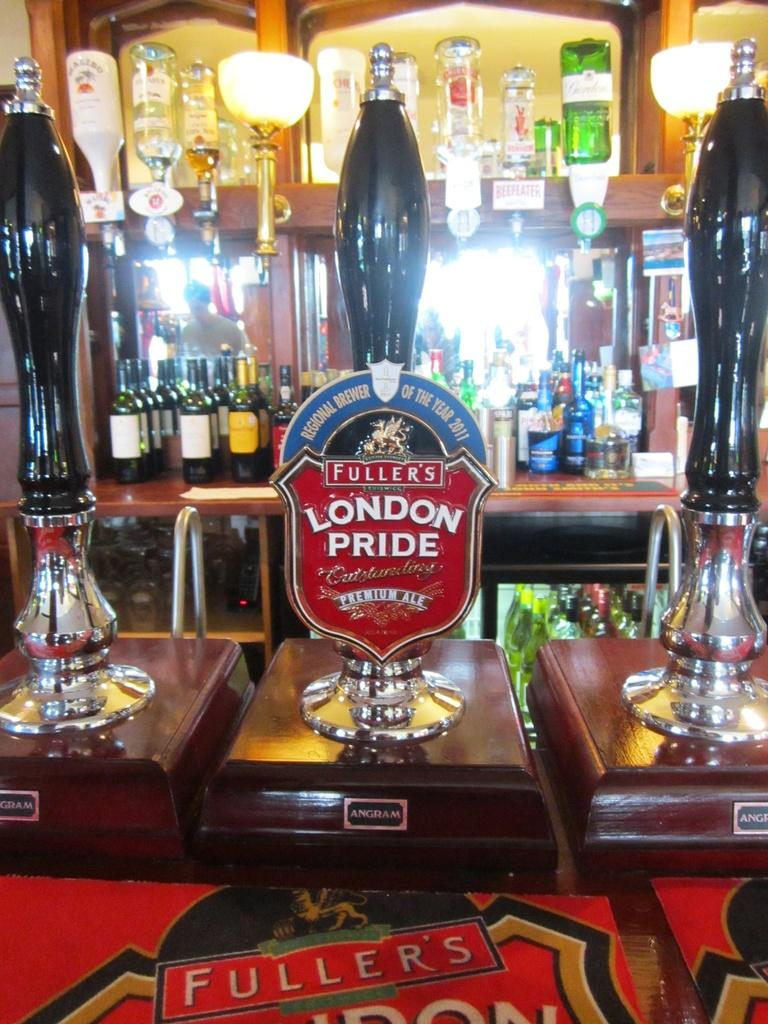<image>
Create a compact narrative representing the image presented. Beer tap with a red sign which says "London Pride" on it. 